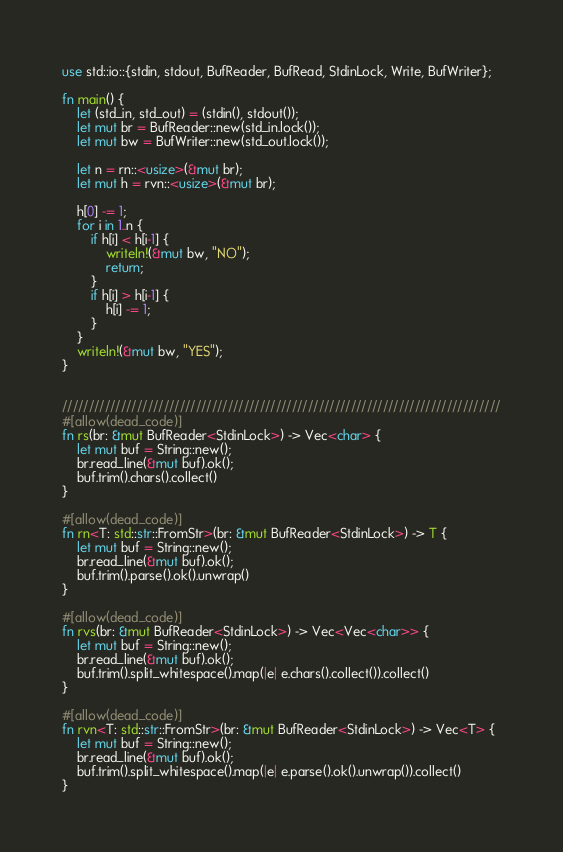Convert code to text. <code><loc_0><loc_0><loc_500><loc_500><_Rust_>use std::io::{stdin, stdout, BufReader, BufRead, StdinLock, Write, BufWriter};

fn main() {
    let (std_in, std_out) = (stdin(), stdout());
    let mut br = BufReader::new(std_in.lock());
    let mut bw = BufWriter::new(std_out.lock());
    
    let n = rn::<usize>(&mut br);
    let mut h = rvn::<usize>(&mut br);

    h[0] -= 1;
    for i in 1..n {
        if h[i] < h[i-1] {
            writeln!(&mut bw, "NO");
            return;
        }
        if h[i] > h[i-1] {
            h[i] -= 1;
        }
    }
    writeln!(&mut bw, "YES");
}


//////////////////////////////////////////////////////////////////////////////////
#[allow(dead_code)]
fn rs(br: &mut BufReader<StdinLock>) -> Vec<char> {
    let mut buf = String::new();
    br.read_line(&mut buf).ok();
    buf.trim().chars().collect()
}

#[allow(dead_code)]
fn rn<T: std::str::FromStr>(br: &mut BufReader<StdinLock>) -> T {
    let mut buf = String::new();
    br.read_line(&mut buf).ok();
    buf.trim().parse().ok().unwrap()
}

#[allow(dead_code)]
fn rvs(br: &mut BufReader<StdinLock>) -> Vec<Vec<char>> {
    let mut buf = String::new();
    br.read_line(&mut buf).ok();
    buf.trim().split_whitespace().map(|e| e.chars().collect()).collect()
}

#[allow(dead_code)]
fn rvn<T: std::str::FromStr>(br: &mut BufReader<StdinLock>) -> Vec<T> {
    let mut buf = String::new();
    br.read_line(&mut buf).ok();
    buf.trim().split_whitespace().map(|e| e.parse().ok().unwrap()).collect()
}</code> 